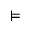<formula> <loc_0><loc_0><loc_500><loc_500>\vDash</formula> 